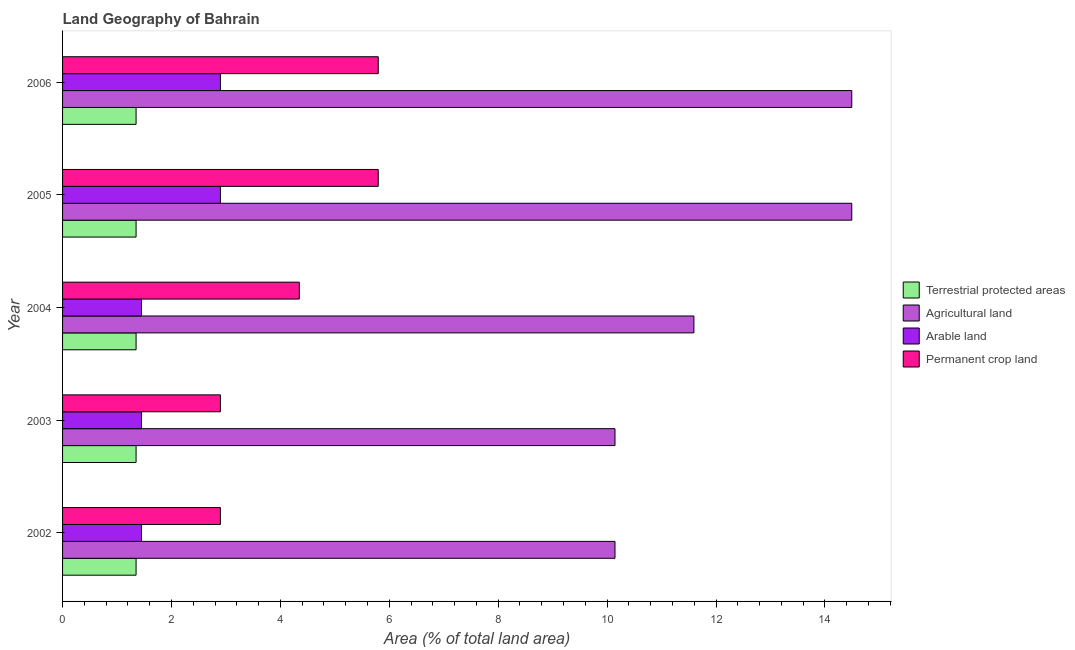How many different coloured bars are there?
Keep it short and to the point. 4. How many groups of bars are there?
Give a very brief answer. 5. Are the number of bars per tick equal to the number of legend labels?
Provide a short and direct response. Yes. Are the number of bars on each tick of the Y-axis equal?
Keep it short and to the point. Yes. How many bars are there on the 3rd tick from the top?
Provide a short and direct response. 4. What is the percentage of area under agricultural land in 2004?
Offer a very short reply. 11.59. Across all years, what is the maximum percentage of area under arable land?
Give a very brief answer. 2.9. Across all years, what is the minimum percentage of area under permanent crop land?
Your response must be concise. 2.9. What is the total percentage of area under arable land in the graph?
Your response must be concise. 10.14. What is the difference between the percentage of area under permanent crop land in 2004 and that in 2005?
Ensure brevity in your answer.  -1.45. What is the difference between the percentage of area under permanent crop land in 2004 and the percentage of area under agricultural land in 2002?
Offer a very short reply. -5.8. What is the average percentage of land under terrestrial protection per year?
Your answer should be very brief. 1.35. In the year 2005, what is the difference between the percentage of area under arable land and percentage of area under agricultural land?
Provide a succinct answer. -11.59. What is the ratio of the percentage of area under agricultural land in 2002 to that in 2005?
Give a very brief answer. 0.7. Is the percentage of area under agricultural land in 2003 less than that in 2004?
Make the answer very short. Yes. What is the difference between the highest and the lowest percentage of area under agricultural land?
Your answer should be compact. 4.35. Is the sum of the percentage of land under terrestrial protection in 2004 and 2005 greater than the maximum percentage of area under agricultural land across all years?
Offer a very short reply. No. What does the 2nd bar from the top in 2003 represents?
Give a very brief answer. Arable land. What does the 4th bar from the bottom in 2003 represents?
Make the answer very short. Permanent crop land. Is it the case that in every year, the sum of the percentage of land under terrestrial protection and percentage of area under agricultural land is greater than the percentage of area under arable land?
Offer a terse response. Yes. What is the difference between two consecutive major ticks on the X-axis?
Your response must be concise. 2. Are the values on the major ticks of X-axis written in scientific E-notation?
Make the answer very short. No. Does the graph contain any zero values?
Offer a very short reply. No. Where does the legend appear in the graph?
Offer a terse response. Center right. How many legend labels are there?
Provide a short and direct response. 4. What is the title of the graph?
Ensure brevity in your answer.  Land Geography of Bahrain. Does "Budget management" appear as one of the legend labels in the graph?
Make the answer very short. No. What is the label or title of the X-axis?
Your answer should be compact. Area (% of total land area). What is the Area (% of total land area) in Terrestrial protected areas in 2002?
Your answer should be very brief. 1.35. What is the Area (% of total land area) of Agricultural land in 2002?
Provide a short and direct response. 10.14. What is the Area (% of total land area) in Arable land in 2002?
Offer a terse response. 1.45. What is the Area (% of total land area) of Permanent crop land in 2002?
Make the answer very short. 2.9. What is the Area (% of total land area) of Terrestrial protected areas in 2003?
Your response must be concise. 1.35. What is the Area (% of total land area) of Agricultural land in 2003?
Give a very brief answer. 10.14. What is the Area (% of total land area) of Arable land in 2003?
Provide a short and direct response. 1.45. What is the Area (% of total land area) of Permanent crop land in 2003?
Make the answer very short. 2.9. What is the Area (% of total land area) in Terrestrial protected areas in 2004?
Keep it short and to the point. 1.35. What is the Area (% of total land area) of Agricultural land in 2004?
Keep it short and to the point. 11.59. What is the Area (% of total land area) of Arable land in 2004?
Ensure brevity in your answer.  1.45. What is the Area (% of total land area) in Permanent crop land in 2004?
Your answer should be compact. 4.35. What is the Area (% of total land area) in Terrestrial protected areas in 2005?
Your answer should be very brief. 1.35. What is the Area (% of total land area) of Agricultural land in 2005?
Make the answer very short. 14.49. What is the Area (% of total land area) in Arable land in 2005?
Make the answer very short. 2.9. What is the Area (% of total land area) of Permanent crop land in 2005?
Your answer should be very brief. 5.8. What is the Area (% of total land area) of Terrestrial protected areas in 2006?
Your answer should be very brief. 1.35. What is the Area (% of total land area) of Agricultural land in 2006?
Your response must be concise. 14.49. What is the Area (% of total land area) in Arable land in 2006?
Provide a short and direct response. 2.9. What is the Area (% of total land area) in Permanent crop land in 2006?
Provide a short and direct response. 5.8. Across all years, what is the maximum Area (% of total land area) in Terrestrial protected areas?
Offer a terse response. 1.35. Across all years, what is the maximum Area (% of total land area) of Agricultural land?
Keep it short and to the point. 14.49. Across all years, what is the maximum Area (% of total land area) in Arable land?
Make the answer very short. 2.9. Across all years, what is the maximum Area (% of total land area) in Permanent crop land?
Ensure brevity in your answer.  5.8. Across all years, what is the minimum Area (% of total land area) in Terrestrial protected areas?
Provide a short and direct response. 1.35. Across all years, what is the minimum Area (% of total land area) of Agricultural land?
Provide a succinct answer. 10.14. Across all years, what is the minimum Area (% of total land area) of Arable land?
Provide a succinct answer. 1.45. Across all years, what is the minimum Area (% of total land area) of Permanent crop land?
Ensure brevity in your answer.  2.9. What is the total Area (% of total land area) in Terrestrial protected areas in the graph?
Make the answer very short. 6.75. What is the total Area (% of total land area) of Agricultural land in the graph?
Keep it short and to the point. 60.87. What is the total Area (% of total land area) of Arable land in the graph?
Your response must be concise. 10.14. What is the total Area (% of total land area) in Permanent crop land in the graph?
Keep it short and to the point. 21.74. What is the difference between the Area (% of total land area) of Terrestrial protected areas in 2002 and that in 2003?
Your answer should be compact. 0. What is the difference between the Area (% of total land area) in Agricultural land in 2002 and that in 2003?
Ensure brevity in your answer.  0. What is the difference between the Area (% of total land area) in Permanent crop land in 2002 and that in 2003?
Offer a very short reply. 0. What is the difference between the Area (% of total land area) in Terrestrial protected areas in 2002 and that in 2004?
Give a very brief answer. 0. What is the difference between the Area (% of total land area) of Agricultural land in 2002 and that in 2004?
Your answer should be very brief. -1.45. What is the difference between the Area (% of total land area) in Permanent crop land in 2002 and that in 2004?
Your response must be concise. -1.45. What is the difference between the Area (% of total land area) of Agricultural land in 2002 and that in 2005?
Keep it short and to the point. -4.35. What is the difference between the Area (% of total land area) in Arable land in 2002 and that in 2005?
Your answer should be compact. -1.45. What is the difference between the Area (% of total land area) in Permanent crop land in 2002 and that in 2005?
Your response must be concise. -2.9. What is the difference between the Area (% of total land area) of Agricultural land in 2002 and that in 2006?
Provide a succinct answer. -4.35. What is the difference between the Area (% of total land area) of Arable land in 2002 and that in 2006?
Offer a terse response. -1.45. What is the difference between the Area (% of total land area) of Permanent crop land in 2002 and that in 2006?
Your answer should be compact. -2.9. What is the difference between the Area (% of total land area) of Terrestrial protected areas in 2003 and that in 2004?
Offer a very short reply. 0. What is the difference between the Area (% of total land area) in Agricultural land in 2003 and that in 2004?
Ensure brevity in your answer.  -1.45. What is the difference between the Area (% of total land area) of Arable land in 2003 and that in 2004?
Your answer should be compact. 0. What is the difference between the Area (% of total land area) in Permanent crop land in 2003 and that in 2004?
Offer a terse response. -1.45. What is the difference between the Area (% of total land area) in Agricultural land in 2003 and that in 2005?
Provide a short and direct response. -4.35. What is the difference between the Area (% of total land area) in Arable land in 2003 and that in 2005?
Your answer should be very brief. -1.45. What is the difference between the Area (% of total land area) of Permanent crop land in 2003 and that in 2005?
Make the answer very short. -2.9. What is the difference between the Area (% of total land area) of Agricultural land in 2003 and that in 2006?
Give a very brief answer. -4.35. What is the difference between the Area (% of total land area) in Arable land in 2003 and that in 2006?
Provide a succinct answer. -1.45. What is the difference between the Area (% of total land area) of Permanent crop land in 2003 and that in 2006?
Provide a succinct answer. -2.9. What is the difference between the Area (% of total land area) of Agricultural land in 2004 and that in 2005?
Make the answer very short. -2.9. What is the difference between the Area (% of total land area) in Arable land in 2004 and that in 2005?
Your answer should be compact. -1.45. What is the difference between the Area (% of total land area) of Permanent crop land in 2004 and that in 2005?
Keep it short and to the point. -1.45. What is the difference between the Area (% of total land area) in Terrestrial protected areas in 2004 and that in 2006?
Provide a succinct answer. 0. What is the difference between the Area (% of total land area) in Agricultural land in 2004 and that in 2006?
Keep it short and to the point. -2.9. What is the difference between the Area (% of total land area) of Arable land in 2004 and that in 2006?
Your answer should be very brief. -1.45. What is the difference between the Area (% of total land area) in Permanent crop land in 2004 and that in 2006?
Provide a succinct answer. -1.45. What is the difference between the Area (% of total land area) in Agricultural land in 2005 and that in 2006?
Your answer should be compact. 0. What is the difference between the Area (% of total land area) of Terrestrial protected areas in 2002 and the Area (% of total land area) of Agricultural land in 2003?
Offer a very short reply. -8.8. What is the difference between the Area (% of total land area) in Terrestrial protected areas in 2002 and the Area (% of total land area) in Arable land in 2003?
Provide a short and direct response. -0.1. What is the difference between the Area (% of total land area) in Terrestrial protected areas in 2002 and the Area (% of total land area) in Permanent crop land in 2003?
Give a very brief answer. -1.55. What is the difference between the Area (% of total land area) of Agricultural land in 2002 and the Area (% of total land area) of Arable land in 2003?
Your response must be concise. 8.7. What is the difference between the Area (% of total land area) in Agricultural land in 2002 and the Area (% of total land area) in Permanent crop land in 2003?
Offer a terse response. 7.25. What is the difference between the Area (% of total land area) of Arable land in 2002 and the Area (% of total land area) of Permanent crop land in 2003?
Offer a terse response. -1.45. What is the difference between the Area (% of total land area) of Terrestrial protected areas in 2002 and the Area (% of total land area) of Agricultural land in 2004?
Your answer should be very brief. -10.24. What is the difference between the Area (% of total land area) in Terrestrial protected areas in 2002 and the Area (% of total land area) in Arable land in 2004?
Ensure brevity in your answer.  -0.1. What is the difference between the Area (% of total land area) of Terrestrial protected areas in 2002 and the Area (% of total land area) of Permanent crop land in 2004?
Ensure brevity in your answer.  -3. What is the difference between the Area (% of total land area) in Agricultural land in 2002 and the Area (% of total land area) in Arable land in 2004?
Give a very brief answer. 8.7. What is the difference between the Area (% of total land area) of Agricultural land in 2002 and the Area (% of total land area) of Permanent crop land in 2004?
Give a very brief answer. 5.8. What is the difference between the Area (% of total land area) in Arable land in 2002 and the Area (% of total land area) in Permanent crop land in 2004?
Give a very brief answer. -2.9. What is the difference between the Area (% of total land area) of Terrestrial protected areas in 2002 and the Area (% of total land area) of Agricultural land in 2005?
Ensure brevity in your answer.  -13.14. What is the difference between the Area (% of total land area) in Terrestrial protected areas in 2002 and the Area (% of total land area) in Arable land in 2005?
Your answer should be compact. -1.55. What is the difference between the Area (% of total land area) of Terrestrial protected areas in 2002 and the Area (% of total land area) of Permanent crop land in 2005?
Your answer should be very brief. -4.45. What is the difference between the Area (% of total land area) of Agricultural land in 2002 and the Area (% of total land area) of Arable land in 2005?
Offer a terse response. 7.25. What is the difference between the Area (% of total land area) in Agricultural land in 2002 and the Area (% of total land area) in Permanent crop land in 2005?
Your response must be concise. 4.35. What is the difference between the Area (% of total land area) of Arable land in 2002 and the Area (% of total land area) of Permanent crop land in 2005?
Offer a very short reply. -4.35. What is the difference between the Area (% of total land area) of Terrestrial protected areas in 2002 and the Area (% of total land area) of Agricultural land in 2006?
Keep it short and to the point. -13.14. What is the difference between the Area (% of total land area) in Terrestrial protected areas in 2002 and the Area (% of total land area) in Arable land in 2006?
Offer a terse response. -1.55. What is the difference between the Area (% of total land area) in Terrestrial protected areas in 2002 and the Area (% of total land area) in Permanent crop land in 2006?
Provide a short and direct response. -4.45. What is the difference between the Area (% of total land area) in Agricultural land in 2002 and the Area (% of total land area) in Arable land in 2006?
Ensure brevity in your answer.  7.25. What is the difference between the Area (% of total land area) in Agricultural land in 2002 and the Area (% of total land area) in Permanent crop land in 2006?
Your response must be concise. 4.35. What is the difference between the Area (% of total land area) in Arable land in 2002 and the Area (% of total land area) in Permanent crop land in 2006?
Give a very brief answer. -4.35. What is the difference between the Area (% of total land area) in Terrestrial protected areas in 2003 and the Area (% of total land area) in Agricultural land in 2004?
Provide a short and direct response. -10.24. What is the difference between the Area (% of total land area) of Terrestrial protected areas in 2003 and the Area (% of total land area) of Arable land in 2004?
Your answer should be very brief. -0.1. What is the difference between the Area (% of total land area) in Terrestrial protected areas in 2003 and the Area (% of total land area) in Permanent crop land in 2004?
Give a very brief answer. -3. What is the difference between the Area (% of total land area) in Agricultural land in 2003 and the Area (% of total land area) in Arable land in 2004?
Offer a terse response. 8.7. What is the difference between the Area (% of total land area) in Agricultural land in 2003 and the Area (% of total land area) in Permanent crop land in 2004?
Provide a short and direct response. 5.8. What is the difference between the Area (% of total land area) in Arable land in 2003 and the Area (% of total land area) in Permanent crop land in 2004?
Provide a succinct answer. -2.9. What is the difference between the Area (% of total land area) in Terrestrial protected areas in 2003 and the Area (% of total land area) in Agricultural land in 2005?
Your answer should be very brief. -13.14. What is the difference between the Area (% of total land area) of Terrestrial protected areas in 2003 and the Area (% of total land area) of Arable land in 2005?
Offer a very short reply. -1.55. What is the difference between the Area (% of total land area) of Terrestrial protected areas in 2003 and the Area (% of total land area) of Permanent crop land in 2005?
Ensure brevity in your answer.  -4.45. What is the difference between the Area (% of total land area) in Agricultural land in 2003 and the Area (% of total land area) in Arable land in 2005?
Ensure brevity in your answer.  7.25. What is the difference between the Area (% of total land area) of Agricultural land in 2003 and the Area (% of total land area) of Permanent crop land in 2005?
Keep it short and to the point. 4.35. What is the difference between the Area (% of total land area) of Arable land in 2003 and the Area (% of total land area) of Permanent crop land in 2005?
Keep it short and to the point. -4.35. What is the difference between the Area (% of total land area) in Terrestrial protected areas in 2003 and the Area (% of total land area) in Agricultural land in 2006?
Give a very brief answer. -13.14. What is the difference between the Area (% of total land area) in Terrestrial protected areas in 2003 and the Area (% of total land area) in Arable land in 2006?
Ensure brevity in your answer.  -1.55. What is the difference between the Area (% of total land area) in Terrestrial protected areas in 2003 and the Area (% of total land area) in Permanent crop land in 2006?
Your answer should be very brief. -4.45. What is the difference between the Area (% of total land area) of Agricultural land in 2003 and the Area (% of total land area) of Arable land in 2006?
Keep it short and to the point. 7.25. What is the difference between the Area (% of total land area) in Agricultural land in 2003 and the Area (% of total land area) in Permanent crop land in 2006?
Ensure brevity in your answer.  4.35. What is the difference between the Area (% of total land area) in Arable land in 2003 and the Area (% of total land area) in Permanent crop land in 2006?
Provide a succinct answer. -4.35. What is the difference between the Area (% of total land area) of Terrestrial protected areas in 2004 and the Area (% of total land area) of Agricultural land in 2005?
Offer a very short reply. -13.14. What is the difference between the Area (% of total land area) of Terrestrial protected areas in 2004 and the Area (% of total land area) of Arable land in 2005?
Provide a succinct answer. -1.55. What is the difference between the Area (% of total land area) of Terrestrial protected areas in 2004 and the Area (% of total land area) of Permanent crop land in 2005?
Make the answer very short. -4.45. What is the difference between the Area (% of total land area) in Agricultural land in 2004 and the Area (% of total land area) in Arable land in 2005?
Ensure brevity in your answer.  8.7. What is the difference between the Area (% of total land area) in Agricultural land in 2004 and the Area (% of total land area) in Permanent crop land in 2005?
Your answer should be very brief. 5.8. What is the difference between the Area (% of total land area) of Arable land in 2004 and the Area (% of total land area) of Permanent crop land in 2005?
Your answer should be compact. -4.35. What is the difference between the Area (% of total land area) of Terrestrial protected areas in 2004 and the Area (% of total land area) of Agricultural land in 2006?
Offer a very short reply. -13.14. What is the difference between the Area (% of total land area) of Terrestrial protected areas in 2004 and the Area (% of total land area) of Arable land in 2006?
Give a very brief answer. -1.55. What is the difference between the Area (% of total land area) in Terrestrial protected areas in 2004 and the Area (% of total land area) in Permanent crop land in 2006?
Offer a very short reply. -4.45. What is the difference between the Area (% of total land area) in Agricultural land in 2004 and the Area (% of total land area) in Arable land in 2006?
Offer a terse response. 8.7. What is the difference between the Area (% of total land area) of Agricultural land in 2004 and the Area (% of total land area) of Permanent crop land in 2006?
Make the answer very short. 5.8. What is the difference between the Area (% of total land area) of Arable land in 2004 and the Area (% of total land area) of Permanent crop land in 2006?
Give a very brief answer. -4.35. What is the difference between the Area (% of total land area) of Terrestrial protected areas in 2005 and the Area (% of total land area) of Agricultural land in 2006?
Offer a very short reply. -13.14. What is the difference between the Area (% of total land area) of Terrestrial protected areas in 2005 and the Area (% of total land area) of Arable land in 2006?
Your response must be concise. -1.55. What is the difference between the Area (% of total land area) of Terrestrial protected areas in 2005 and the Area (% of total land area) of Permanent crop land in 2006?
Offer a terse response. -4.45. What is the difference between the Area (% of total land area) of Agricultural land in 2005 and the Area (% of total land area) of Arable land in 2006?
Ensure brevity in your answer.  11.59. What is the difference between the Area (% of total land area) in Agricultural land in 2005 and the Area (% of total land area) in Permanent crop land in 2006?
Give a very brief answer. 8.7. What is the difference between the Area (% of total land area) in Arable land in 2005 and the Area (% of total land area) in Permanent crop land in 2006?
Keep it short and to the point. -2.9. What is the average Area (% of total land area) in Terrestrial protected areas per year?
Provide a short and direct response. 1.35. What is the average Area (% of total land area) in Agricultural land per year?
Provide a short and direct response. 12.17. What is the average Area (% of total land area) in Arable land per year?
Your response must be concise. 2.03. What is the average Area (% of total land area) of Permanent crop land per year?
Ensure brevity in your answer.  4.35. In the year 2002, what is the difference between the Area (% of total land area) of Terrestrial protected areas and Area (% of total land area) of Agricultural land?
Your answer should be compact. -8.8. In the year 2002, what is the difference between the Area (% of total land area) in Terrestrial protected areas and Area (% of total land area) in Arable land?
Your response must be concise. -0.1. In the year 2002, what is the difference between the Area (% of total land area) of Terrestrial protected areas and Area (% of total land area) of Permanent crop land?
Offer a very short reply. -1.55. In the year 2002, what is the difference between the Area (% of total land area) in Agricultural land and Area (% of total land area) in Arable land?
Provide a short and direct response. 8.7. In the year 2002, what is the difference between the Area (% of total land area) in Agricultural land and Area (% of total land area) in Permanent crop land?
Give a very brief answer. 7.25. In the year 2002, what is the difference between the Area (% of total land area) in Arable land and Area (% of total land area) in Permanent crop land?
Offer a very short reply. -1.45. In the year 2003, what is the difference between the Area (% of total land area) in Terrestrial protected areas and Area (% of total land area) in Agricultural land?
Provide a succinct answer. -8.8. In the year 2003, what is the difference between the Area (% of total land area) in Terrestrial protected areas and Area (% of total land area) in Arable land?
Give a very brief answer. -0.1. In the year 2003, what is the difference between the Area (% of total land area) of Terrestrial protected areas and Area (% of total land area) of Permanent crop land?
Provide a short and direct response. -1.55. In the year 2003, what is the difference between the Area (% of total land area) of Agricultural land and Area (% of total land area) of Arable land?
Provide a succinct answer. 8.7. In the year 2003, what is the difference between the Area (% of total land area) of Agricultural land and Area (% of total land area) of Permanent crop land?
Keep it short and to the point. 7.25. In the year 2003, what is the difference between the Area (% of total land area) of Arable land and Area (% of total land area) of Permanent crop land?
Your answer should be compact. -1.45. In the year 2004, what is the difference between the Area (% of total land area) of Terrestrial protected areas and Area (% of total land area) of Agricultural land?
Your response must be concise. -10.24. In the year 2004, what is the difference between the Area (% of total land area) in Terrestrial protected areas and Area (% of total land area) in Arable land?
Make the answer very short. -0.1. In the year 2004, what is the difference between the Area (% of total land area) of Terrestrial protected areas and Area (% of total land area) of Permanent crop land?
Offer a very short reply. -3. In the year 2004, what is the difference between the Area (% of total land area) of Agricultural land and Area (% of total land area) of Arable land?
Ensure brevity in your answer.  10.14. In the year 2004, what is the difference between the Area (% of total land area) in Agricultural land and Area (% of total land area) in Permanent crop land?
Give a very brief answer. 7.25. In the year 2004, what is the difference between the Area (% of total land area) of Arable land and Area (% of total land area) of Permanent crop land?
Ensure brevity in your answer.  -2.9. In the year 2005, what is the difference between the Area (% of total land area) in Terrestrial protected areas and Area (% of total land area) in Agricultural land?
Provide a short and direct response. -13.14. In the year 2005, what is the difference between the Area (% of total land area) in Terrestrial protected areas and Area (% of total land area) in Arable land?
Make the answer very short. -1.55. In the year 2005, what is the difference between the Area (% of total land area) of Terrestrial protected areas and Area (% of total land area) of Permanent crop land?
Your response must be concise. -4.45. In the year 2005, what is the difference between the Area (% of total land area) of Agricultural land and Area (% of total land area) of Arable land?
Keep it short and to the point. 11.59. In the year 2005, what is the difference between the Area (% of total land area) of Agricultural land and Area (% of total land area) of Permanent crop land?
Make the answer very short. 8.7. In the year 2005, what is the difference between the Area (% of total land area) in Arable land and Area (% of total land area) in Permanent crop land?
Offer a terse response. -2.9. In the year 2006, what is the difference between the Area (% of total land area) in Terrestrial protected areas and Area (% of total land area) in Agricultural land?
Offer a terse response. -13.14. In the year 2006, what is the difference between the Area (% of total land area) of Terrestrial protected areas and Area (% of total land area) of Arable land?
Your answer should be compact. -1.55. In the year 2006, what is the difference between the Area (% of total land area) in Terrestrial protected areas and Area (% of total land area) in Permanent crop land?
Give a very brief answer. -4.45. In the year 2006, what is the difference between the Area (% of total land area) of Agricultural land and Area (% of total land area) of Arable land?
Provide a succinct answer. 11.59. In the year 2006, what is the difference between the Area (% of total land area) in Agricultural land and Area (% of total land area) in Permanent crop land?
Offer a very short reply. 8.7. In the year 2006, what is the difference between the Area (% of total land area) of Arable land and Area (% of total land area) of Permanent crop land?
Provide a succinct answer. -2.9. What is the ratio of the Area (% of total land area) in Terrestrial protected areas in 2002 to that in 2003?
Provide a succinct answer. 1. What is the ratio of the Area (% of total land area) in Agricultural land in 2002 to that in 2003?
Your answer should be very brief. 1. What is the ratio of the Area (% of total land area) of Arable land in 2002 to that in 2003?
Keep it short and to the point. 1. What is the ratio of the Area (% of total land area) of Terrestrial protected areas in 2002 to that in 2004?
Offer a very short reply. 1. What is the ratio of the Area (% of total land area) in Arable land in 2002 to that in 2004?
Make the answer very short. 1. What is the ratio of the Area (% of total land area) of Terrestrial protected areas in 2002 to that in 2005?
Ensure brevity in your answer.  1. What is the ratio of the Area (% of total land area) in Agricultural land in 2002 to that in 2005?
Keep it short and to the point. 0.7. What is the ratio of the Area (% of total land area) of Agricultural land in 2002 to that in 2006?
Offer a very short reply. 0.7. What is the ratio of the Area (% of total land area) in Permanent crop land in 2002 to that in 2006?
Keep it short and to the point. 0.5. What is the ratio of the Area (% of total land area) in Terrestrial protected areas in 2003 to that in 2004?
Provide a short and direct response. 1. What is the ratio of the Area (% of total land area) of Arable land in 2003 to that in 2004?
Offer a very short reply. 1. What is the ratio of the Area (% of total land area) in Terrestrial protected areas in 2003 to that in 2005?
Ensure brevity in your answer.  1. What is the ratio of the Area (% of total land area) of Agricultural land in 2003 to that in 2005?
Ensure brevity in your answer.  0.7. What is the ratio of the Area (% of total land area) in Permanent crop land in 2003 to that in 2005?
Ensure brevity in your answer.  0.5. What is the ratio of the Area (% of total land area) in Terrestrial protected areas in 2003 to that in 2006?
Provide a succinct answer. 1. What is the ratio of the Area (% of total land area) in Agricultural land in 2003 to that in 2006?
Make the answer very short. 0.7. What is the ratio of the Area (% of total land area) of Permanent crop land in 2003 to that in 2006?
Provide a succinct answer. 0.5. What is the ratio of the Area (% of total land area) of Permanent crop land in 2004 to that in 2005?
Your answer should be very brief. 0.75. What is the ratio of the Area (% of total land area) in Terrestrial protected areas in 2004 to that in 2006?
Provide a succinct answer. 1. What is the ratio of the Area (% of total land area) of Permanent crop land in 2004 to that in 2006?
Your response must be concise. 0.75. What is the ratio of the Area (% of total land area) in Terrestrial protected areas in 2005 to that in 2006?
Make the answer very short. 1. What is the ratio of the Area (% of total land area) of Arable land in 2005 to that in 2006?
Offer a very short reply. 1. What is the difference between the highest and the second highest Area (% of total land area) of Terrestrial protected areas?
Offer a very short reply. 0. What is the difference between the highest and the second highest Area (% of total land area) in Agricultural land?
Offer a terse response. 0. What is the difference between the highest and the second highest Area (% of total land area) in Permanent crop land?
Give a very brief answer. 0. What is the difference between the highest and the lowest Area (% of total land area) of Agricultural land?
Offer a terse response. 4.35. What is the difference between the highest and the lowest Area (% of total land area) in Arable land?
Make the answer very short. 1.45. What is the difference between the highest and the lowest Area (% of total land area) of Permanent crop land?
Offer a very short reply. 2.9. 